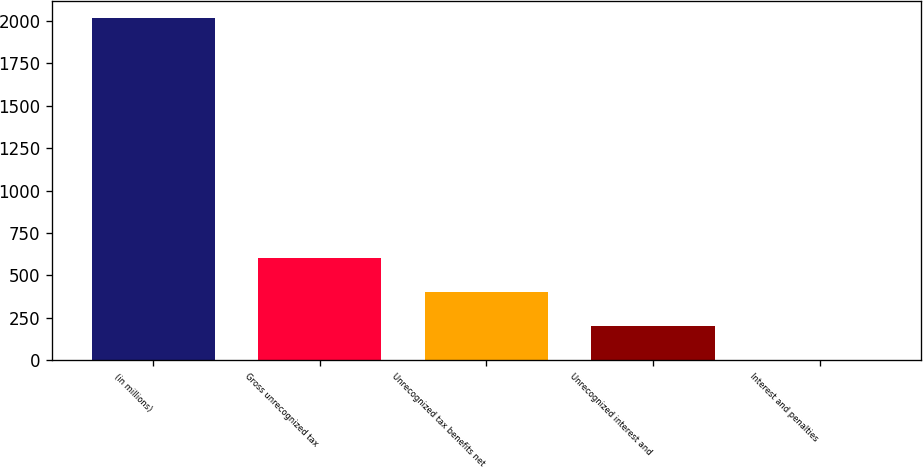Convert chart. <chart><loc_0><loc_0><loc_500><loc_500><bar_chart><fcel>(in millions)<fcel>Gross unrecognized tax<fcel>Unrecognized tax benefits net<fcel>Unrecognized interest and<fcel>Interest and penalties<nl><fcel>2017<fcel>606.01<fcel>404.44<fcel>202.87<fcel>1.3<nl></chart> 